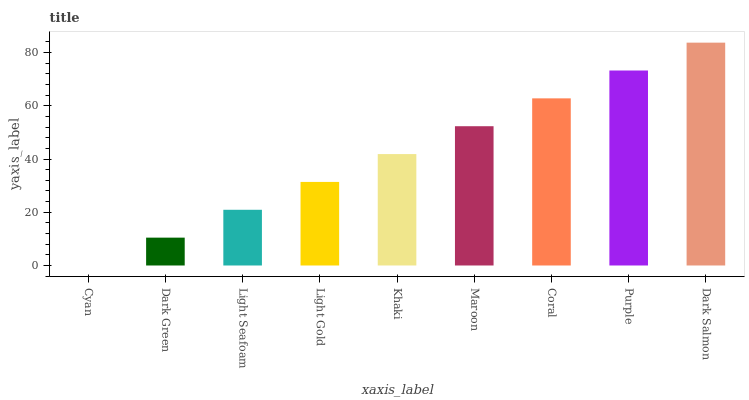Is Cyan the minimum?
Answer yes or no. Yes. Is Dark Salmon the maximum?
Answer yes or no. Yes. Is Dark Green the minimum?
Answer yes or no. No. Is Dark Green the maximum?
Answer yes or no. No. Is Dark Green greater than Cyan?
Answer yes or no. Yes. Is Cyan less than Dark Green?
Answer yes or no. Yes. Is Cyan greater than Dark Green?
Answer yes or no. No. Is Dark Green less than Cyan?
Answer yes or no. No. Is Khaki the high median?
Answer yes or no. Yes. Is Khaki the low median?
Answer yes or no. Yes. Is Maroon the high median?
Answer yes or no. No. Is Maroon the low median?
Answer yes or no. No. 